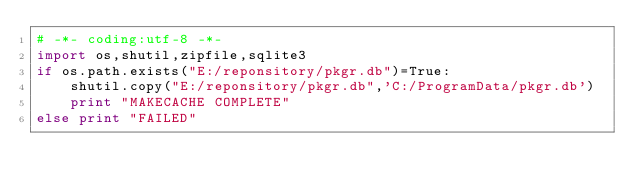<code> <loc_0><loc_0><loc_500><loc_500><_Python_># -*- coding:utf-8 -*-
import os,shutil,zipfile,sqlite3
if os.path.exists("E:/reponsitory/pkgr.db")=True:
    shutil.copy("E:/reponsitory/pkgr.db",'C:/ProgramData/pkgr.db')
    print "MAKECACHE COMPLETE"
else print "FAILED"
</code> 